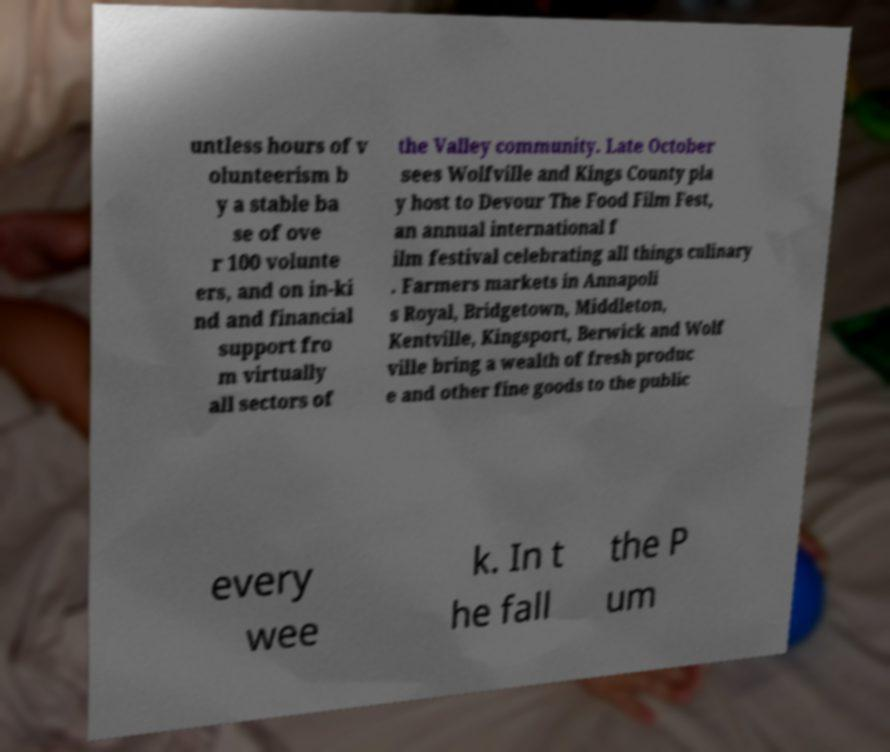Could you extract and type out the text from this image? untless hours of v olunteerism b y a stable ba se of ove r 100 volunte ers, and on in-ki nd and financial support fro m virtually all sectors of the Valley community. Late October sees Wolfville and Kings County pla y host to Devour The Food Film Fest, an annual international f ilm festival celebrating all things culinary . Farmers markets in Annapoli s Royal, Bridgetown, Middleton, Kentville, Kingsport, Berwick and Wolf ville bring a wealth of fresh produc e and other fine goods to the public every wee k. In t he fall the P um 